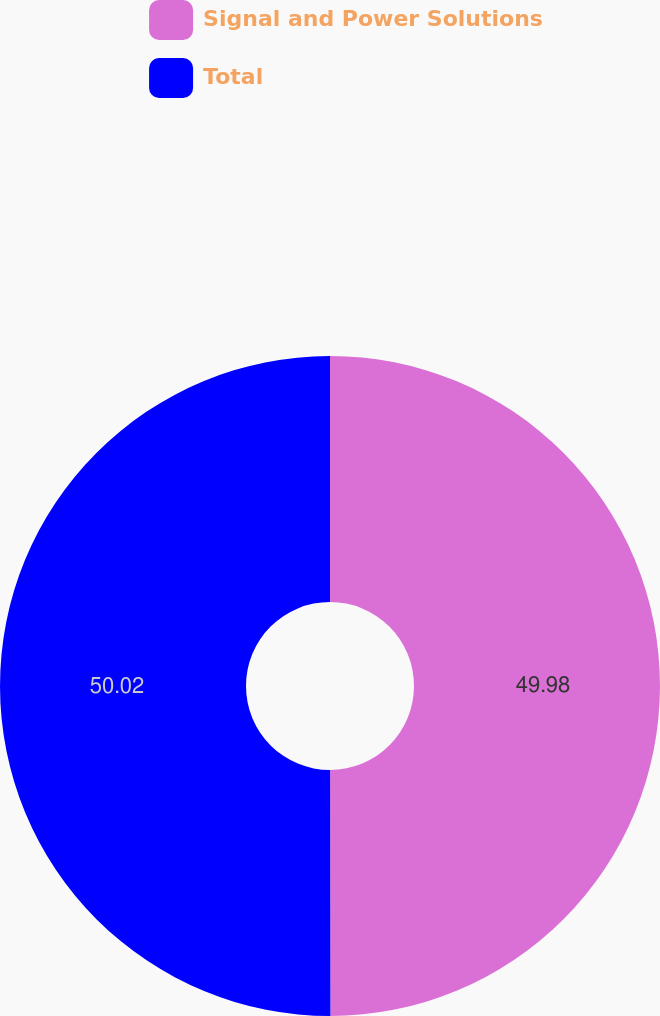Convert chart. <chart><loc_0><loc_0><loc_500><loc_500><pie_chart><fcel>Signal and Power Solutions<fcel>Total<nl><fcel>49.98%<fcel>50.02%<nl></chart> 